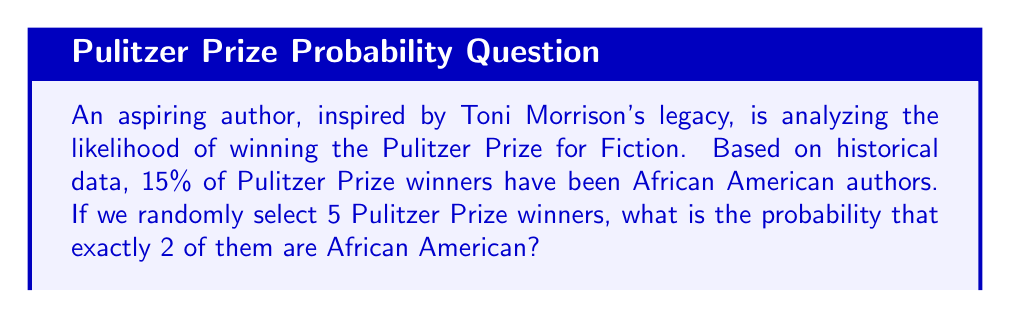Could you help me with this problem? To solve this problem, we'll use the Binomial Probability formula, as we're dealing with a fixed number of independent trials (selecting 5 winners) with two possible outcomes for each trial (African American author or not).

Let's define our variables:
$n = 5$ (number of selections)
$k = 2$ (number of successes we're looking for)
$p = 0.15$ (probability of success on each trial)
$q = 1 - p = 0.85$ (probability of failure on each trial)

The Binomial Probability formula is:

$$P(X = k) = \binom{n}{k} p^k q^{n-k}$$

Where $\binom{n}{k}$ is the binomial coefficient, calculated as:

$$\binom{n}{k} = \frac{n!}{k!(n-k)!}$$

Step 1: Calculate the binomial coefficient
$$\binom{5}{2} = \frac{5!}{2!(5-2)!} = \frac{5 \cdot 4}{2 \cdot 1} = 10$$

Step 2: Apply the Binomial Probability formula
$$P(X = 2) = 10 \cdot (0.15)^2 \cdot (0.85)^{5-2}$$
$$= 10 \cdot (0.15)^2 \cdot (0.85)^3$$
$$= 10 \cdot 0.0225 \cdot 0.614125$$
$$= 0.138178125$$

Step 3: Convert to a percentage
$$0.138178125 \cdot 100\% = 13.82\%$$

Therefore, the probability of selecting exactly 2 African American authors when randomly choosing 5 Pulitzer Prize winners is approximately 13.82%.
Answer: 13.82% 